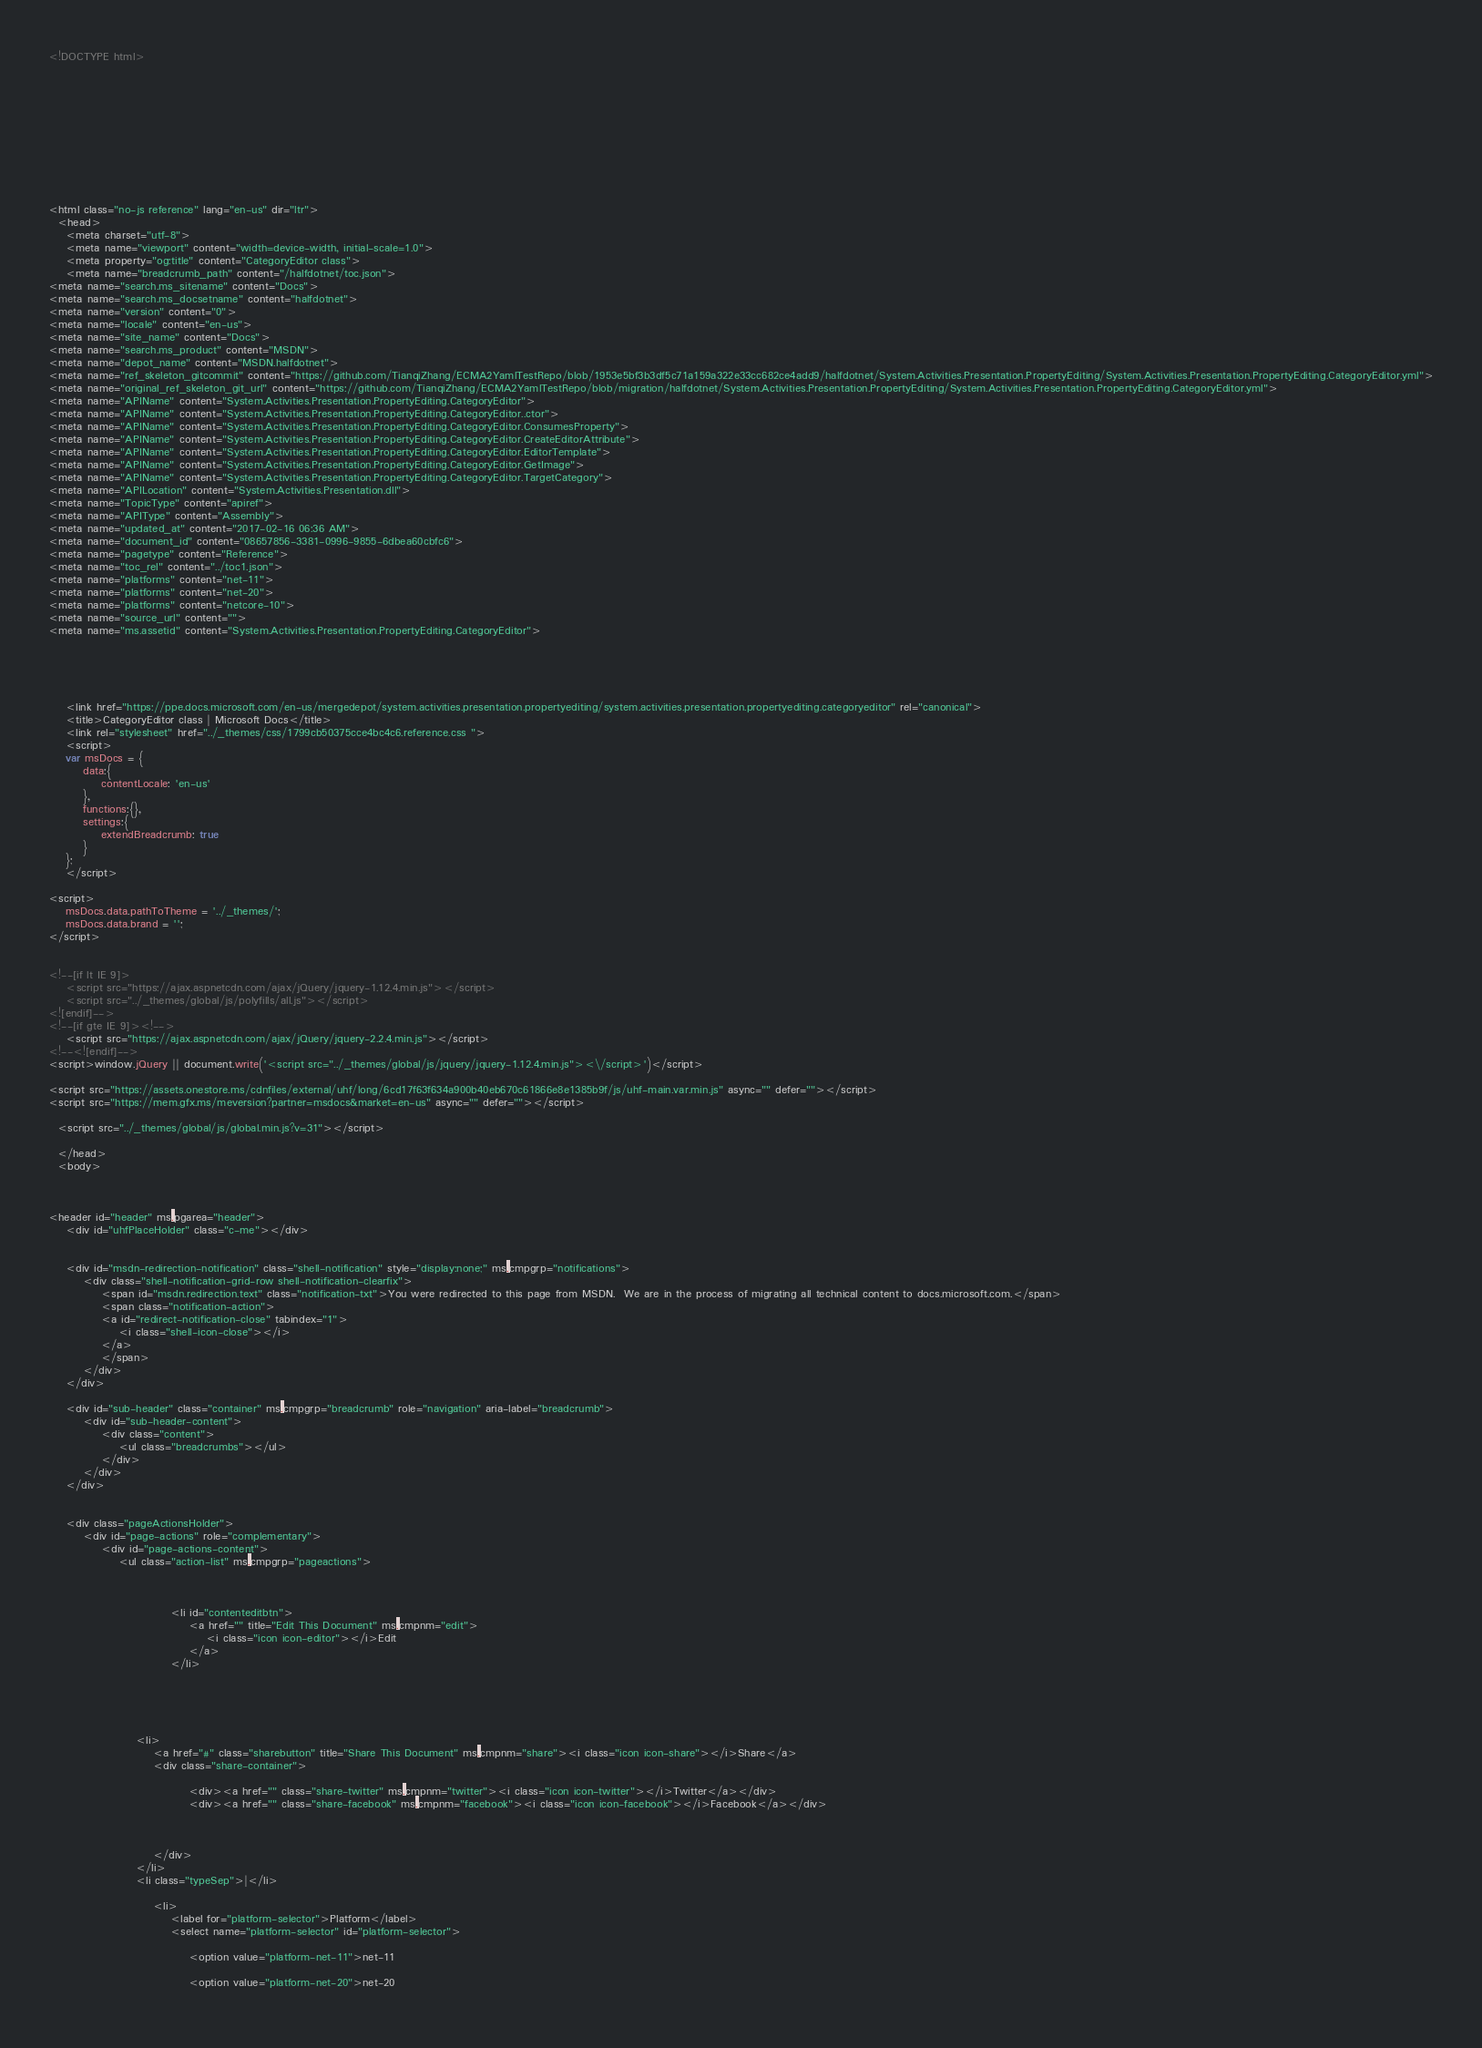Convert code to text. <code><loc_0><loc_0><loc_500><loc_500><_HTML_><!DOCTYPE html>



  


  


  

<html class="no-js reference" lang="en-us" dir="ltr">
  <head>
    <meta charset="utf-8">
    <meta name="viewport" content="width=device-width, initial-scale=1.0">
    <meta property="og:title" content="CategoryEditor class">
    <meta name="breadcrumb_path" content="/halfdotnet/toc.json">
<meta name="search.ms_sitename" content="Docs">
<meta name="search.ms_docsetname" content="halfdotnet">
<meta name="version" content="0">
<meta name="locale" content="en-us">
<meta name="site_name" content="Docs">
<meta name="search.ms_product" content="MSDN">
<meta name="depot_name" content="MSDN.halfdotnet">
<meta name="ref_skeleton_gitcommit" content="https://github.com/TianqiZhang/ECMA2YamlTestRepo/blob/1953e5bf3b3df5c71a159a322e33cc682ce4add9/halfdotnet/System.Activities.Presentation.PropertyEditing/System.Activities.Presentation.PropertyEditing.CategoryEditor.yml">
<meta name="original_ref_skeleton_git_url" content="https://github.com/TianqiZhang/ECMA2YamlTestRepo/blob/migration/halfdotnet/System.Activities.Presentation.PropertyEditing/System.Activities.Presentation.PropertyEditing.CategoryEditor.yml">
<meta name="APIName" content="System.Activities.Presentation.PropertyEditing.CategoryEditor">
<meta name="APIName" content="System.Activities.Presentation.PropertyEditing.CategoryEditor..ctor">
<meta name="APIName" content="System.Activities.Presentation.PropertyEditing.CategoryEditor.ConsumesProperty">
<meta name="APIName" content="System.Activities.Presentation.PropertyEditing.CategoryEditor.CreateEditorAttribute">
<meta name="APIName" content="System.Activities.Presentation.PropertyEditing.CategoryEditor.EditorTemplate">
<meta name="APIName" content="System.Activities.Presentation.PropertyEditing.CategoryEditor.GetImage">
<meta name="APIName" content="System.Activities.Presentation.PropertyEditing.CategoryEditor.TargetCategory">
<meta name="APILocation" content="System.Activities.Presentation.dll">
<meta name="TopicType" content="apiref">
<meta name="APIType" content="Assembly">
<meta name="updated_at" content="2017-02-16 06:36 AM">
<meta name="document_id" content="08657856-3381-0996-9855-6dbea60cbfc6">
<meta name="pagetype" content="Reference">
<meta name="toc_rel" content="../toc1.json">
<meta name="platforms" content="net-11">
<meta name="platforms" content="net-20">
<meta name="platforms" content="netcore-10">
<meta name="source_url" content="">
<meta name="ms.assetid" content="System.Activities.Presentation.PropertyEditing.CategoryEditor">

    
    
      
    
    <link href="https://ppe.docs.microsoft.com/en-us/mergedepot/system.activities.presentation.propertyediting/system.activities.presentation.propertyediting.categoryeditor" rel="canonical">
    <title>CategoryEditor class | Microsoft Docs</title>
    <link rel="stylesheet" href="../_themes/css/1799cb50375cce4bc4c6.reference.css ">
    <script>
	var msDocs = {
		data:{
			contentLocale: 'en-us'
		},
		functions:{},
		settings:{
			extendBreadcrumb: true
		}
	};
	</script>

<script>
	msDocs.data.pathToTheme = '../_themes/';
	msDocs.data.brand = '';
</script>


<!--[if lt IE 9]>
	<script src="https://ajax.aspnetcdn.com/ajax/jQuery/jquery-1.12.4.min.js"></script>
	<script src="../_themes/global/js/polyfills/all.js"></script>
<![endif]-->
<!--[if gte IE 9]><!-->
	<script src="https://ajax.aspnetcdn.com/ajax/jQuery/jquery-2.2.4.min.js"></script>
<!--<![endif]-->
<script>window.jQuery || document.write('<script src="../_themes/global/js/jquery/jquery-1.12.4.min.js"><\/script>')</script>

<script src="https://assets.onestore.ms/cdnfiles/external/uhf/long/6cd17f63f634a900b40eb670c61866e8e1385b9f/js/uhf-main.var.min.js" async="" defer=""></script>
<script src="https://mem.gfx.ms/meversion?partner=msdocs&market=en-us" async="" defer=""></script>

  <script src="../_themes/global/js/global.min.js?v=31"></script>

  </head>
  <body>



<header id="header" ms.pgarea="header">
    <div id="uhfPlaceHolder" class="c-me"></div>

    
    <div id="msdn-redirection-notification" class="shell-notification" style="display:none;" ms.cmpgrp="notifications">
        <div class="shell-notification-grid-row shell-notification-clearfix">
            <span id="msdn.redirection.text" class="notification-txt">You were redirected to this page from MSDN.  We are in the process of migrating all technical content to docs.microsoft.com.</span>
            <span class="notification-action">
            <a id="redirect-notification-close" tabindex="1">
                <i class="shell-icon-close"></i>
            </a>
            </span>
        </div>        
    </div>

    <div id="sub-header" class="container" ms.cmpgrp="breadcrumb" role="navigation" aria-label="breadcrumb">    
        <div id="sub-header-content">
            <div class="content">
                <ul class="breadcrumbs"></ul>
            </div>
        </div>
    </div>


    <div class="pageActionsHolder">
        <div id="page-actions" role="complementary">
            <div id="page-actions-content">
                <ul class="action-list" ms.cmpgrp="pageactions">
                    
                    
                                                
                            <li id="contenteditbtn">
                                <a href="" title="Edit This Document" ms.cmpnm="edit">
                                    <i class="icon icon-editor"></i>Edit
                                </a>
                            </li>
                        
                    
					
						
					
                    <li>
                        <a href="#" class="sharebutton" title="Share This Document" ms.cmpnm="share"><i class="icon icon-share"></i>Share</a>
                        <div class="share-container">
                            
                                <div><a href="" class="share-twitter" ms.cmpnm="twitter"><i class="icon icon-twitter"></i>Twitter</a></div>
                                <div><a href="" class="share-facebook" ms.cmpnm="facebook"><i class="icon icon-facebook"></i>Facebook</a></div>
                            
                            
                            
                        </div>
                    </li>
                    <li class="typeSep">|</li>
                    
                        <li>
                            <label for="platform-selector">Platform</label>									
                            <select name="platform-selector" id="platform-selector">
                                
                                <option value="platform-net-11">net-11
                                
                                <option value="platform-net-20">net-20
                                </code> 